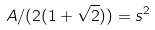<formula> <loc_0><loc_0><loc_500><loc_500>A / ( 2 ( 1 + \sqrt { 2 } ) ) = s ^ { 2 }</formula> 